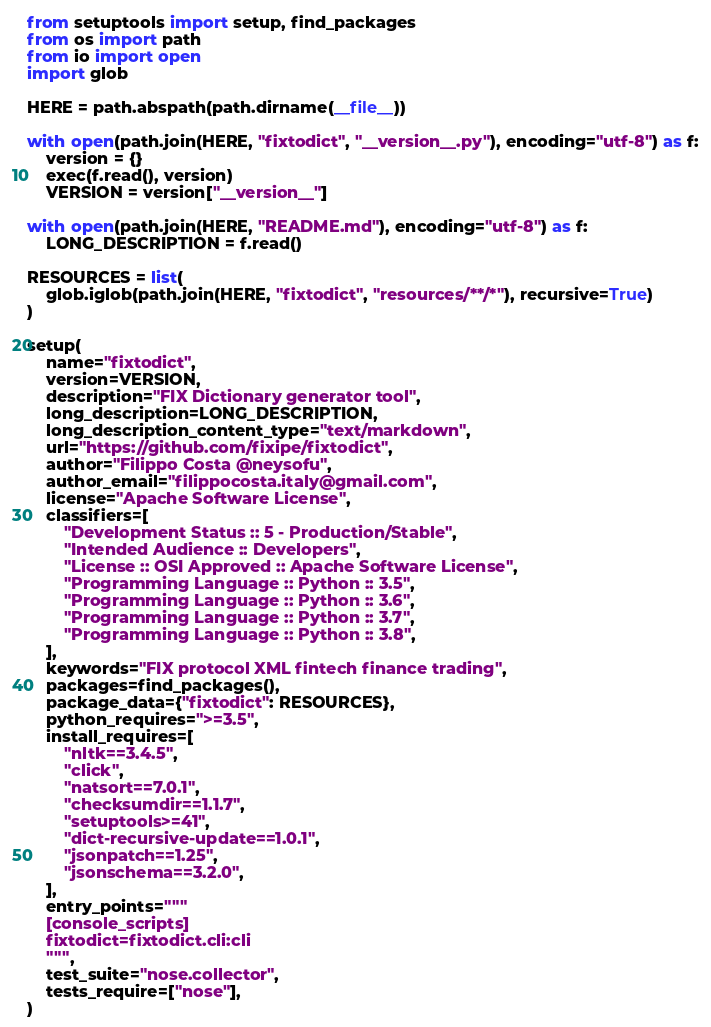Convert code to text. <code><loc_0><loc_0><loc_500><loc_500><_Python_>from setuptools import setup, find_packages
from os import path
from io import open
import glob

HERE = path.abspath(path.dirname(__file__))

with open(path.join(HERE, "fixtodict", "__version__.py"), encoding="utf-8") as f:
    version = {}
    exec(f.read(), version)
    VERSION = version["__version__"]

with open(path.join(HERE, "README.md"), encoding="utf-8") as f:
    LONG_DESCRIPTION = f.read()

RESOURCES = list(
    glob.iglob(path.join(HERE, "fixtodict", "resources/**/*"), recursive=True)
)

setup(
    name="fixtodict",
    version=VERSION,
    description="FIX Dictionary generator tool",
    long_description=LONG_DESCRIPTION,
    long_description_content_type="text/markdown",
    url="https://github.com/fixipe/fixtodict",
    author="Filippo Costa @neysofu",
    author_email="filippocosta.italy@gmail.com",
    license="Apache Software License",
    classifiers=[
        "Development Status :: 5 - Production/Stable",
        "Intended Audience :: Developers",
        "License :: OSI Approved :: Apache Software License",
        "Programming Language :: Python :: 3.5",
        "Programming Language :: Python :: 3.6",
        "Programming Language :: Python :: 3.7",
        "Programming Language :: Python :: 3.8",
    ],
    keywords="FIX protocol XML fintech finance trading",
    packages=find_packages(),
    package_data={"fixtodict": RESOURCES},
    python_requires=">=3.5",
    install_requires=[
        "nltk==3.4.5",
        "click",
        "natsort==7.0.1",
        "checksumdir==1.1.7",
        "setuptools>=41",
        "dict-recursive-update==1.0.1",
        "jsonpatch==1.25",
        "jsonschema==3.2.0",
    ],
    entry_points="""
    [console_scripts]
    fixtodict=fixtodict.cli:cli
    """,
    test_suite="nose.collector",
    tests_require=["nose"],
)
</code> 